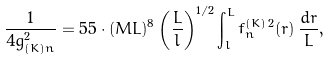Convert formula to latex. <formula><loc_0><loc_0><loc_500><loc_500>\frac { 1 } { 4 g _ { ( K ) n } ^ { 2 } } = 5 5 \cdot ( M L ) ^ { 8 } \left ( \frac { L } { l } \right ) ^ { 1 / 2 } \int _ { l } ^ { L } f ^ { ( K ) \, 2 } _ { n } ( r ) \, \frac { d r } { L } ,</formula> 